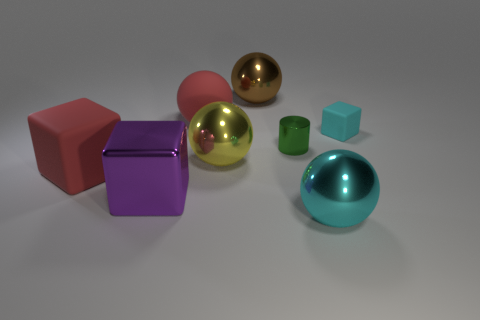Are there any other things that are the same material as the cyan sphere?
Give a very brief answer. Yes. What is the size of the metallic ball that is behind the tiny cyan block that is behind the big purple thing?
Give a very brief answer. Large. Is the number of small rubber cubes that are behind the tiny matte object the same as the number of green objects?
Offer a very short reply. No. What number of other things are the same color as the small rubber thing?
Your answer should be compact. 1. Is the number of tiny metallic objects that are to the left of the green shiny cylinder less than the number of yellow balls?
Give a very brief answer. Yes. Are there any matte spheres of the same size as the purple shiny cube?
Ensure brevity in your answer.  Yes. There is a large matte sphere; is its color the same as the cube that is right of the large purple block?
Your response must be concise. No. What number of cyan shiny spheres are to the right of the block to the right of the big brown metal ball?
Your answer should be very brief. 0. What is the color of the tiny object that is to the left of the cube on the right side of the large matte ball?
Ensure brevity in your answer.  Green. What material is the object that is behind the green object and to the right of the cylinder?
Your answer should be very brief. Rubber. 